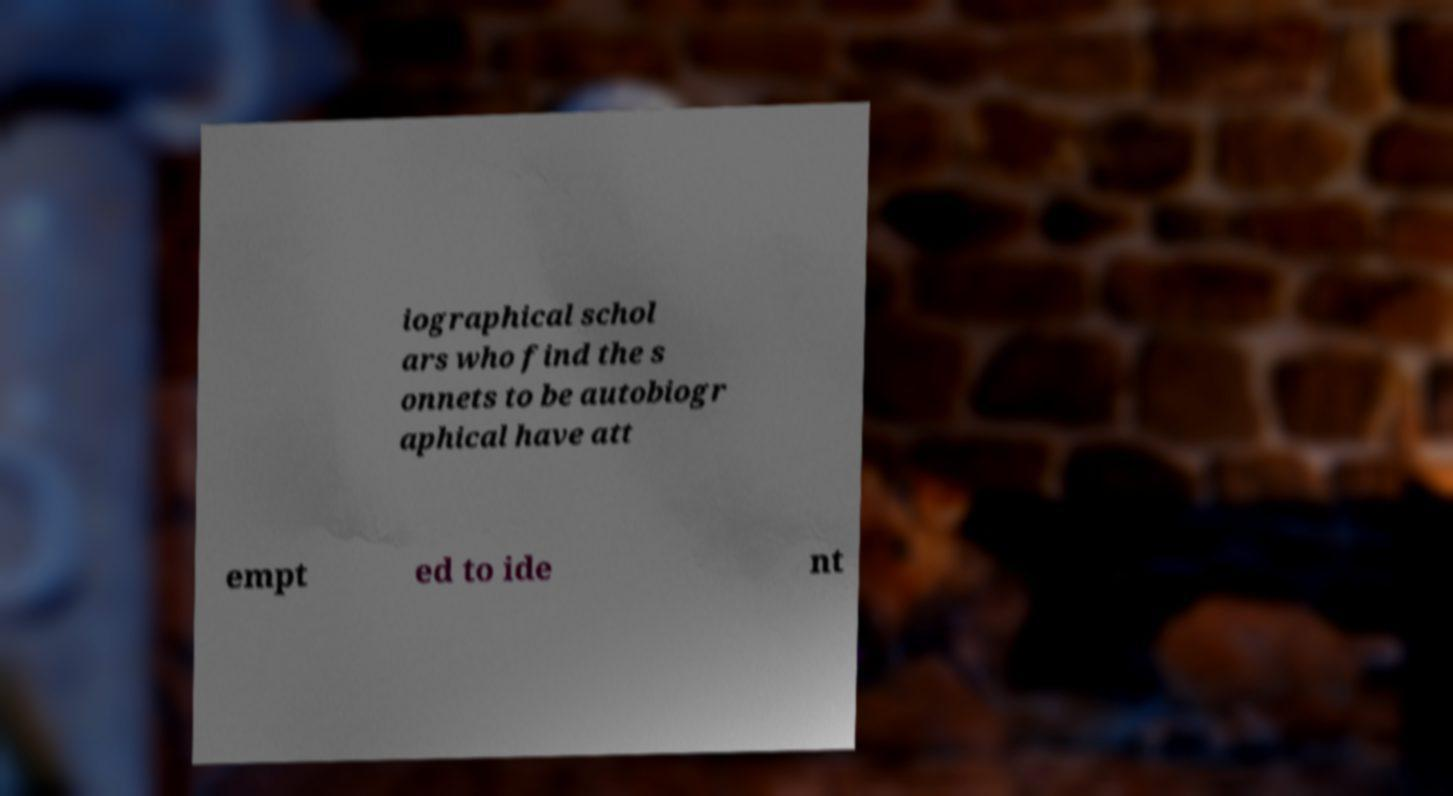For documentation purposes, I need the text within this image transcribed. Could you provide that? iographical schol ars who find the s onnets to be autobiogr aphical have att empt ed to ide nt 